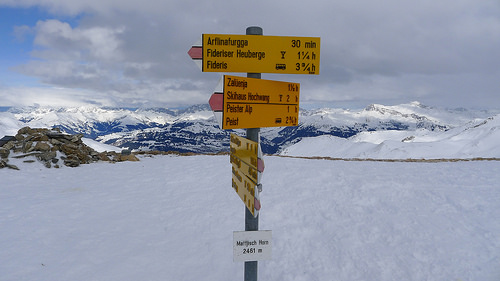<image>
Can you confirm if the board is next to the sky? No. The board is not positioned next to the sky. They are located in different areas of the scene. 